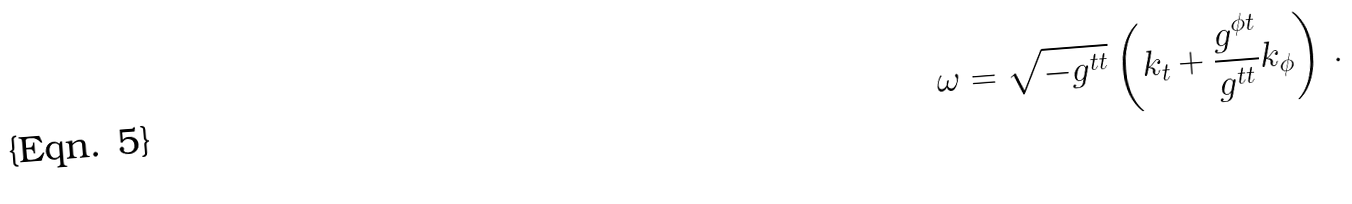Convert formula to latex. <formula><loc_0><loc_0><loc_500><loc_500>\omega = \sqrt { - g ^ { t t } } \left ( k _ { t } + \frac { g ^ { \phi t } } { g ^ { t t } } k _ { \phi } \right ) \, .</formula> 